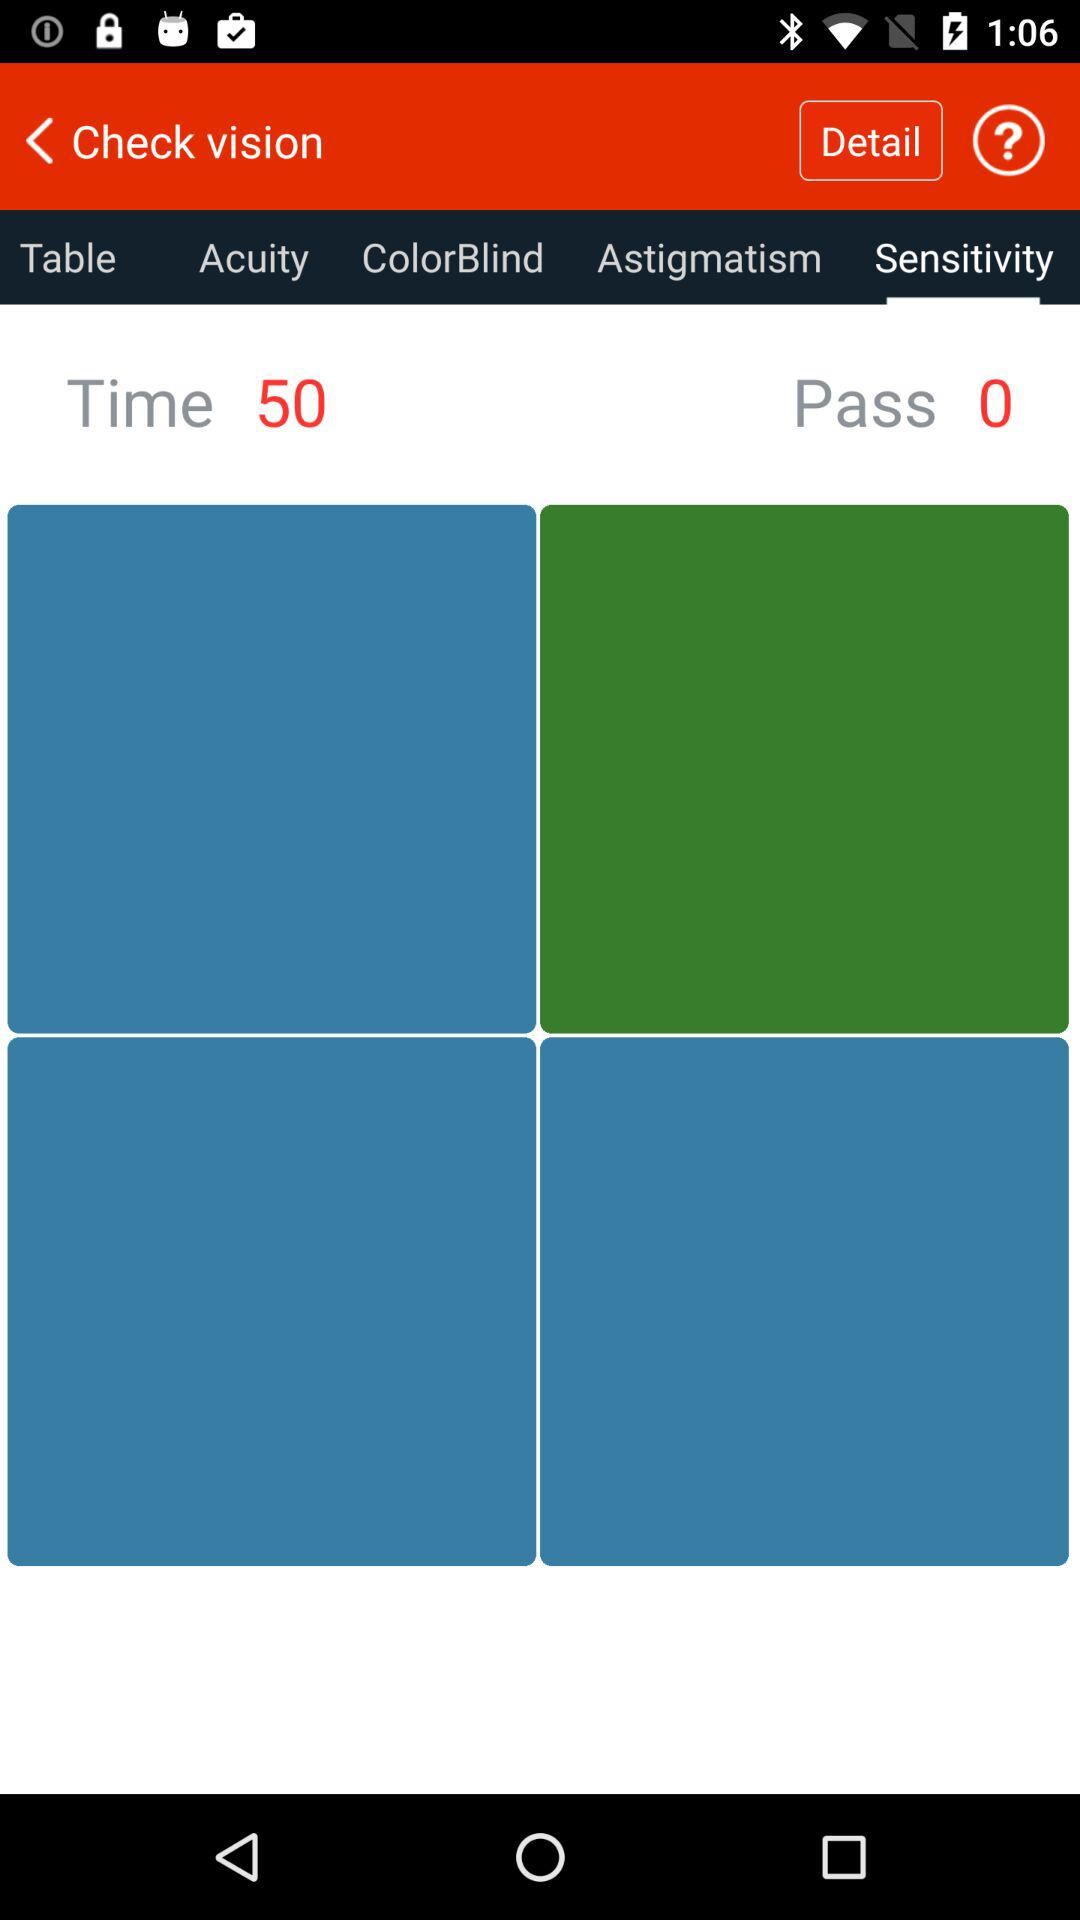What is the given time? The given time is 50. 